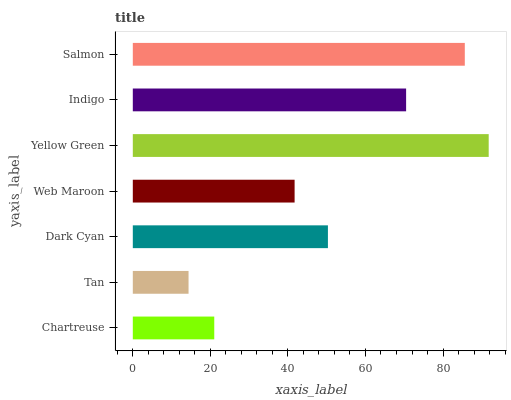Is Tan the minimum?
Answer yes or no. Yes. Is Yellow Green the maximum?
Answer yes or no. Yes. Is Dark Cyan the minimum?
Answer yes or no. No. Is Dark Cyan the maximum?
Answer yes or no. No. Is Dark Cyan greater than Tan?
Answer yes or no. Yes. Is Tan less than Dark Cyan?
Answer yes or no. Yes. Is Tan greater than Dark Cyan?
Answer yes or no. No. Is Dark Cyan less than Tan?
Answer yes or no. No. Is Dark Cyan the high median?
Answer yes or no. Yes. Is Dark Cyan the low median?
Answer yes or no. Yes. Is Web Maroon the high median?
Answer yes or no. No. Is Salmon the low median?
Answer yes or no. No. 